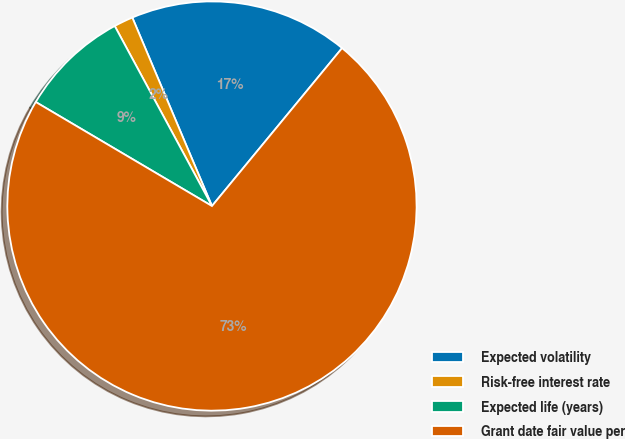Convert chart to OTSL. <chart><loc_0><loc_0><loc_500><loc_500><pie_chart><fcel>Expected volatility<fcel>Risk-free interest rate<fcel>Expected life (years)<fcel>Grant date fair value per<nl><fcel>17.33%<fcel>1.52%<fcel>8.63%<fcel>72.52%<nl></chart> 